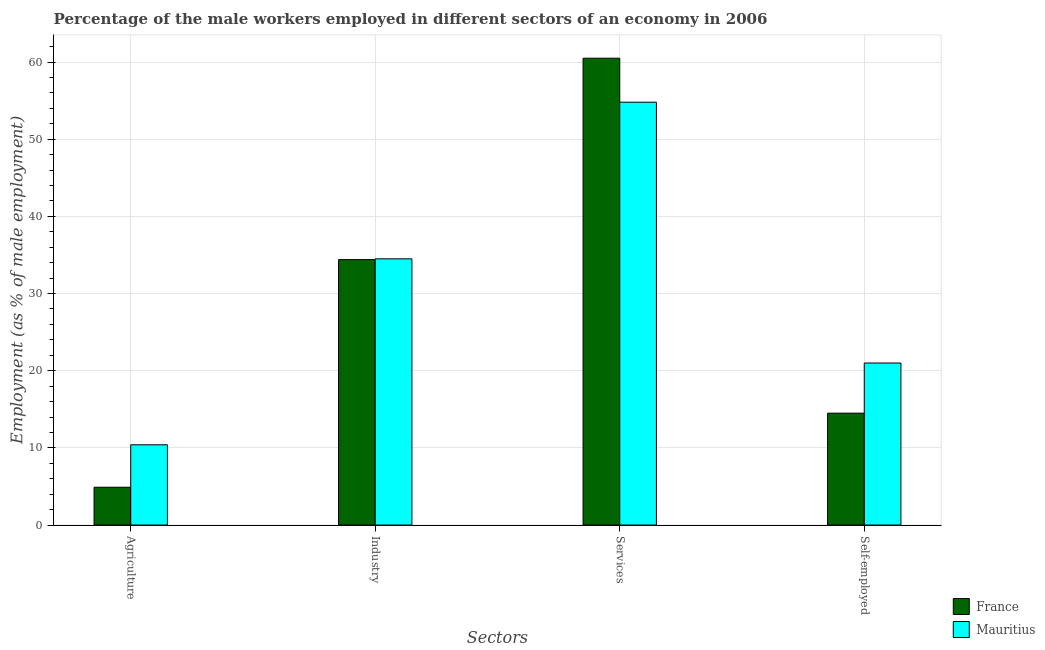How many different coloured bars are there?
Provide a short and direct response. 2. What is the label of the 3rd group of bars from the left?
Your response must be concise. Services. What is the percentage of male workers in industry in Mauritius?
Give a very brief answer. 34.5. Across all countries, what is the maximum percentage of male workers in industry?
Your response must be concise. 34.5. Across all countries, what is the minimum percentage of male workers in industry?
Provide a succinct answer. 34.4. In which country was the percentage of male workers in services maximum?
Your response must be concise. France. What is the total percentage of male workers in industry in the graph?
Your response must be concise. 68.9. What is the difference between the percentage of male workers in services in Mauritius and that in France?
Keep it short and to the point. -5.7. What is the difference between the percentage of male workers in services in France and the percentage of male workers in agriculture in Mauritius?
Your answer should be compact. 50.1. What is the average percentage of male workers in industry per country?
Your answer should be compact. 34.45. What is the difference between the percentage of male workers in industry and percentage of male workers in agriculture in France?
Offer a very short reply. 29.5. In how many countries, is the percentage of self employed male workers greater than 2 %?
Offer a terse response. 2. What is the ratio of the percentage of male workers in services in France to that in Mauritius?
Offer a terse response. 1.1. Is the difference between the percentage of male workers in services in Mauritius and France greater than the difference between the percentage of self employed male workers in Mauritius and France?
Your response must be concise. No. What is the difference between the highest and the second highest percentage of male workers in industry?
Offer a very short reply. 0.1. What is the difference between the highest and the lowest percentage of male workers in agriculture?
Make the answer very short. 5.5. In how many countries, is the percentage of male workers in industry greater than the average percentage of male workers in industry taken over all countries?
Make the answer very short. 1. Is it the case that in every country, the sum of the percentage of male workers in services and percentage of male workers in industry is greater than the sum of percentage of self employed male workers and percentage of male workers in agriculture?
Your answer should be very brief. Yes. What does the 1st bar from the left in Agriculture represents?
Keep it short and to the point. France. What does the 1st bar from the right in Services represents?
Your answer should be compact. Mauritius. How many bars are there?
Ensure brevity in your answer.  8. Are all the bars in the graph horizontal?
Ensure brevity in your answer.  No. How many countries are there in the graph?
Your answer should be very brief. 2. Are the values on the major ticks of Y-axis written in scientific E-notation?
Give a very brief answer. No. Does the graph contain grids?
Keep it short and to the point. Yes. Where does the legend appear in the graph?
Provide a short and direct response. Bottom right. How many legend labels are there?
Provide a succinct answer. 2. What is the title of the graph?
Your answer should be very brief. Percentage of the male workers employed in different sectors of an economy in 2006. Does "Mauritania" appear as one of the legend labels in the graph?
Keep it short and to the point. No. What is the label or title of the X-axis?
Your answer should be compact. Sectors. What is the label or title of the Y-axis?
Your answer should be compact. Employment (as % of male employment). What is the Employment (as % of male employment) of France in Agriculture?
Ensure brevity in your answer.  4.9. What is the Employment (as % of male employment) of Mauritius in Agriculture?
Your answer should be compact. 10.4. What is the Employment (as % of male employment) of France in Industry?
Give a very brief answer. 34.4. What is the Employment (as % of male employment) of Mauritius in Industry?
Your response must be concise. 34.5. What is the Employment (as % of male employment) of France in Services?
Keep it short and to the point. 60.5. What is the Employment (as % of male employment) of Mauritius in Services?
Offer a very short reply. 54.8. What is the Employment (as % of male employment) in France in Self-employed?
Provide a short and direct response. 14.5. What is the Employment (as % of male employment) in Mauritius in Self-employed?
Your answer should be very brief. 21. Across all Sectors, what is the maximum Employment (as % of male employment) of France?
Your answer should be compact. 60.5. Across all Sectors, what is the maximum Employment (as % of male employment) of Mauritius?
Your response must be concise. 54.8. Across all Sectors, what is the minimum Employment (as % of male employment) of France?
Give a very brief answer. 4.9. Across all Sectors, what is the minimum Employment (as % of male employment) of Mauritius?
Offer a terse response. 10.4. What is the total Employment (as % of male employment) of France in the graph?
Offer a terse response. 114.3. What is the total Employment (as % of male employment) in Mauritius in the graph?
Provide a short and direct response. 120.7. What is the difference between the Employment (as % of male employment) in France in Agriculture and that in Industry?
Provide a short and direct response. -29.5. What is the difference between the Employment (as % of male employment) in Mauritius in Agriculture and that in Industry?
Your answer should be compact. -24.1. What is the difference between the Employment (as % of male employment) of France in Agriculture and that in Services?
Your answer should be compact. -55.6. What is the difference between the Employment (as % of male employment) of Mauritius in Agriculture and that in Services?
Give a very brief answer. -44.4. What is the difference between the Employment (as % of male employment) in France in Agriculture and that in Self-employed?
Your answer should be very brief. -9.6. What is the difference between the Employment (as % of male employment) of France in Industry and that in Services?
Keep it short and to the point. -26.1. What is the difference between the Employment (as % of male employment) in Mauritius in Industry and that in Services?
Your response must be concise. -20.3. What is the difference between the Employment (as % of male employment) in Mauritius in Services and that in Self-employed?
Make the answer very short. 33.8. What is the difference between the Employment (as % of male employment) of France in Agriculture and the Employment (as % of male employment) of Mauritius in Industry?
Your answer should be very brief. -29.6. What is the difference between the Employment (as % of male employment) in France in Agriculture and the Employment (as % of male employment) in Mauritius in Services?
Keep it short and to the point. -49.9. What is the difference between the Employment (as % of male employment) of France in Agriculture and the Employment (as % of male employment) of Mauritius in Self-employed?
Your answer should be very brief. -16.1. What is the difference between the Employment (as % of male employment) of France in Industry and the Employment (as % of male employment) of Mauritius in Services?
Make the answer very short. -20.4. What is the difference between the Employment (as % of male employment) in France in Services and the Employment (as % of male employment) in Mauritius in Self-employed?
Your answer should be compact. 39.5. What is the average Employment (as % of male employment) in France per Sectors?
Give a very brief answer. 28.57. What is the average Employment (as % of male employment) of Mauritius per Sectors?
Provide a succinct answer. 30.18. What is the difference between the Employment (as % of male employment) in France and Employment (as % of male employment) in Mauritius in Agriculture?
Provide a short and direct response. -5.5. What is the difference between the Employment (as % of male employment) of France and Employment (as % of male employment) of Mauritius in Industry?
Offer a terse response. -0.1. What is the ratio of the Employment (as % of male employment) of France in Agriculture to that in Industry?
Your response must be concise. 0.14. What is the ratio of the Employment (as % of male employment) in Mauritius in Agriculture to that in Industry?
Ensure brevity in your answer.  0.3. What is the ratio of the Employment (as % of male employment) in France in Agriculture to that in Services?
Offer a terse response. 0.08. What is the ratio of the Employment (as % of male employment) in Mauritius in Agriculture to that in Services?
Provide a short and direct response. 0.19. What is the ratio of the Employment (as % of male employment) of France in Agriculture to that in Self-employed?
Give a very brief answer. 0.34. What is the ratio of the Employment (as % of male employment) of Mauritius in Agriculture to that in Self-employed?
Offer a very short reply. 0.5. What is the ratio of the Employment (as % of male employment) of France in Industry to that in Services?
Keep it short and to the point. 0.57. What is the ratio of the Employment (as % of male employment) of Mauritius in Industry to that in Services?
Keep it short and to the point. 0.63. What is the ratio of the Employment (as % of male employment) of France in Industry to that in Self-employed?
Your answer should be compact. 2.37. What is the ratio of the Employment (as % of male employment) in Mauritius in Industry to that in Self-employed?
Keep it short and to the point. 1.64. What is the ratio of the Employment (as % of male employment) of France in Services to that in Self-employed?
Keep it short and to the point. 4.17. What is the ratio of the Employment (as % of male employment) of Mauritius in Services to that in Self-employed?
Offer a terse response. 2.61. What is the difference between the highest and the second highest Employment (as % of male employment) in France?
Your response must be concise. 26.1. What is the difference between the highest and the second highest Employment (as % of male employment) in Mauritius?
Give a very brief answer. 20.3. What is the difference between the highest and the lowest Employment (as % of male employment) of France?
Make the answer very short. 55.6. What is the difference between the highest and the lowest Employment (as % of male employment) of Mauritius?
Provide a short and direct response. 44.4. 